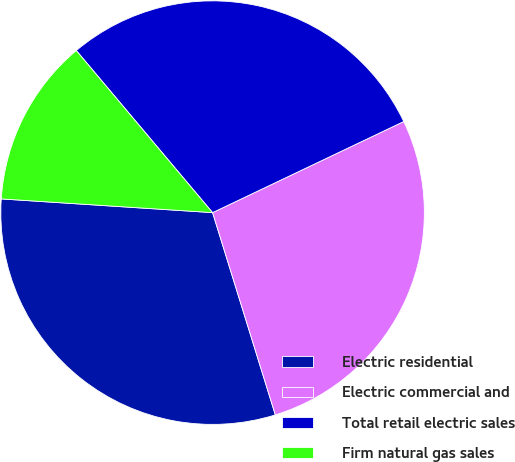Convert chart to OTSL. <chart><loc_0><loc_0><loc_500><loc_500><pie_chart><fcel>Electric residential<fcel>Electric commercial and<fcel>Total retail electric sales<fcel>Firm natural gas sales<nl><fcel>30.82%<fcel>27.29%<fcel>29.05%<fcel>12.84%<nl></chart> 